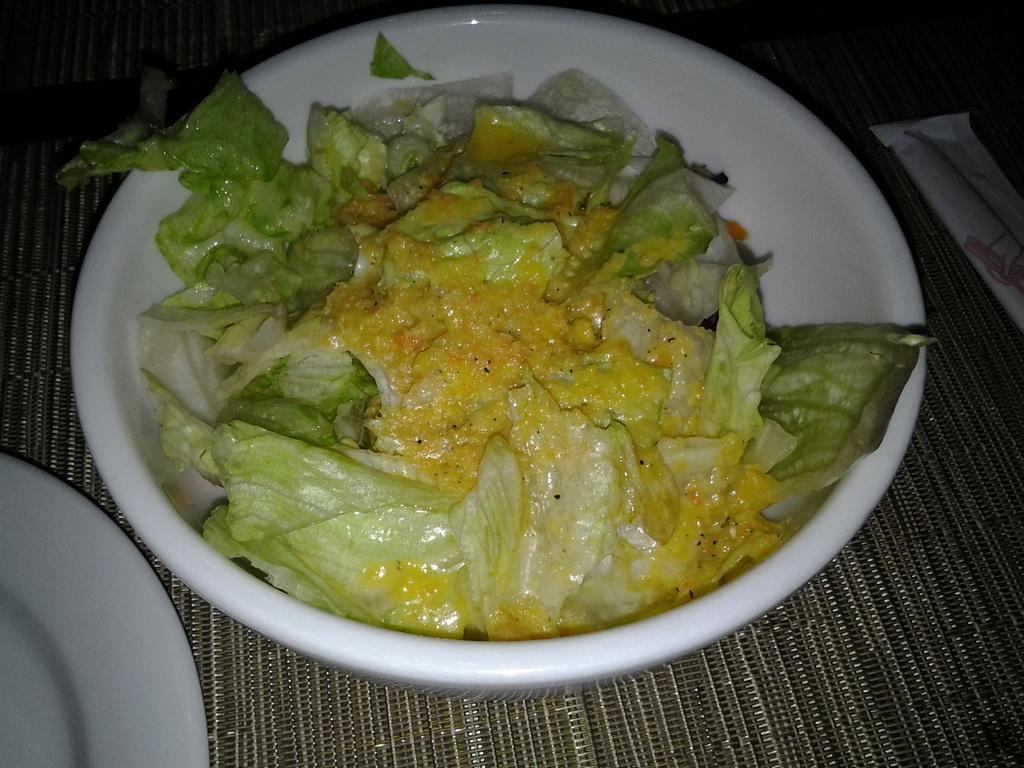What is on the table in the image? There are plates on a table in the image. What is in the plates? There is food in the plates. Can you describe the object on the right side of the image? Unfortunately, the provided facts do not give any information about the object on the right side of the image. How many bees are sitting on the coat in the image? There is no coat or bees present in the image. What type of bird can be seen flying over the plates in the image? There are no birds present in the image; it only shows plates with food on a table. 